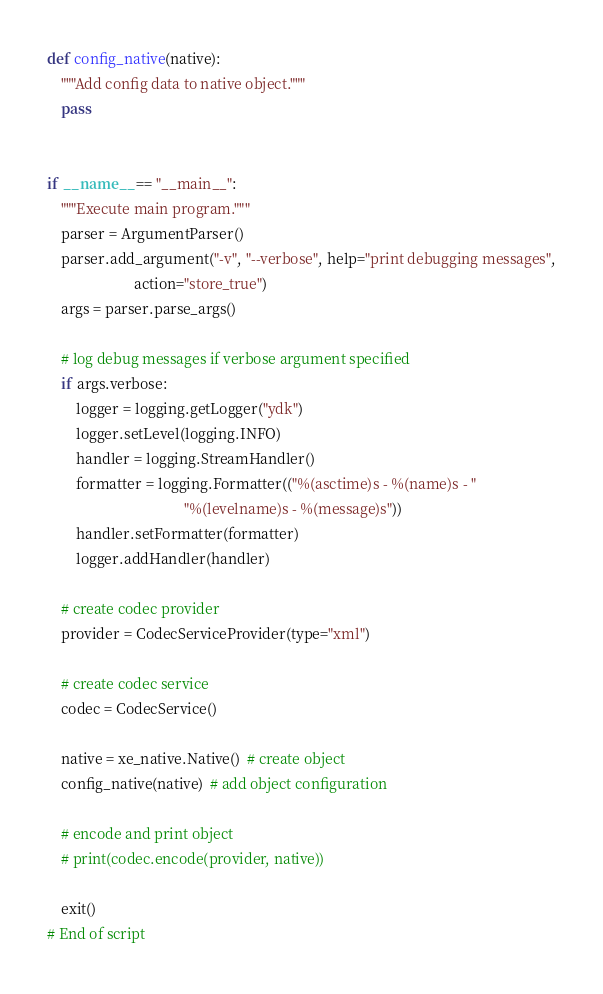Convert code to text. <code><loc_0><loc_0><loc_500><loc_500><_Python_>
def config_native(native):
    """Add config data to native object."""
    pass


if __name__ == "__main__":
    """Execute main program."""
    parser = ArgumentParser()
    parser.add_argument("-v", "--verbose", help="print debugging messages",
                        action="store_true")
    args = parser.parse_args()

    # log debug messages if verbose argument specified
    if args.verbose:
        logger = logging.getLogger("ydk")
        logger.setLevel(logging.INFO)
        handler = logging.StreamHandler()
        formatter = logging.Formatter(("%(asctime)s - %(name)s - "
                                      "%(levelname)s - %(message)s"))
        handler.setFormatter(formatter)
        logger.addHandler(handler)

    # create codec provider
    provider = CodecServiceProvider(type="xml")

    # create codec service
    codec = CodecService()

    native = xe_native.Native()  # create object
    config_native(native)  # add object configuration

    # encode and print object
    # print(codec.encode(provider, native))

    exit()
# End of script
</code> 